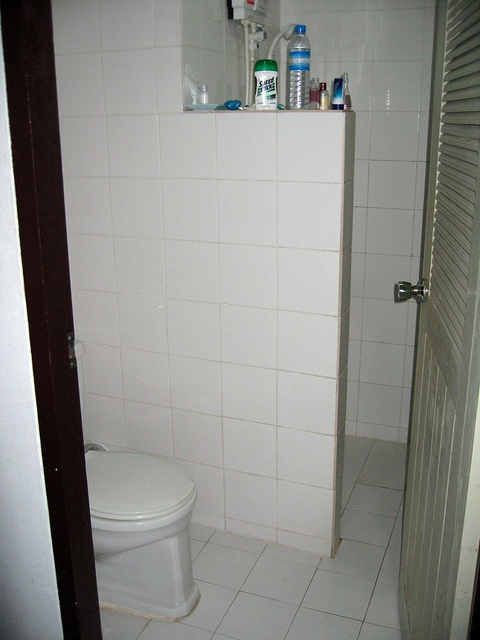Describe the objects in this image and their specific colors. I can see toilet in black, darkgray, and gray tones, bottle in black, gray, darkgray, and blue tones, bottle in black, gray, maroon, darkgray, and purple tones, bottle in black and gray tones, and bottle in black, gray, tan, and darkgray tones in this image. 